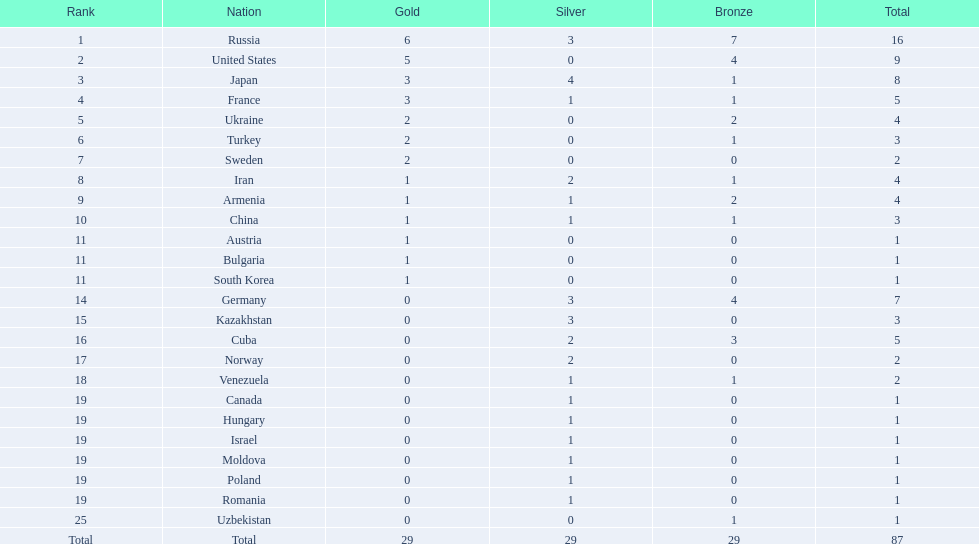Which nations achieved fewer than 5 medals? Ukraine, Turkey, Sweden, Iran, Armenia, China, Austria, Bulgaria, South Korea, Germany, Kazakhstan, Norway, Venezuela, Canada, Hungary, Israel, Moldova, Poland, Romania, Uzbekistan. Of these, which ones are not asian countries? Ukraine, Turkey, Sweden, Iran, Armenia, Austria, Bulgaria, Germany, Kazakhstan, Norway, Venezuela, Canada, Hungary, Israel, Moldova, Poland, Romania, Uzbekistan. From those, which did not win any silver medals? Ukraine, Turkey, Sweden, Austria, Bulgaria, Uzbekistan. Among them, which had only one total medal? Austria, Bulgaria, Uzbekistan. Which of these would be ranked first alphabetically? Austria. 